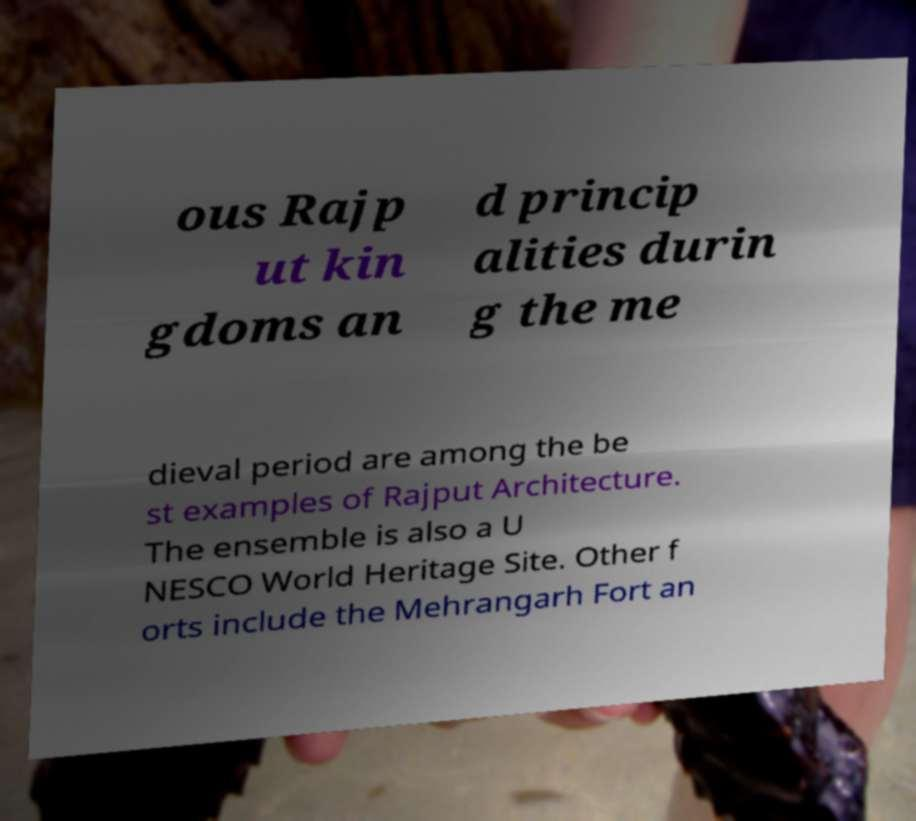Please identify and transcribe the text found in this image. ous Rajp ut kin gdoms an d princip alities durin g the me dieval period are among the be st examples of Rajput Architecture. The ensemble is also a U NESCO World Heritage Site. Other f orts include the Mehrangarh Fort an 